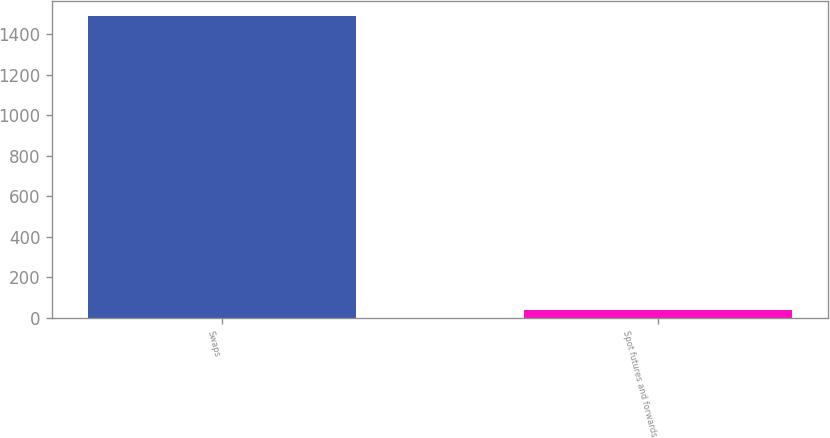Convert chart to OTSL. <chart><loc_0><loc_0><loc_500><loc_500><bar_chart><fcel>Swaps<fcel>Spot futures and forwards<nl><fcel>1490.7<fcel>37.2<nl></chart> 